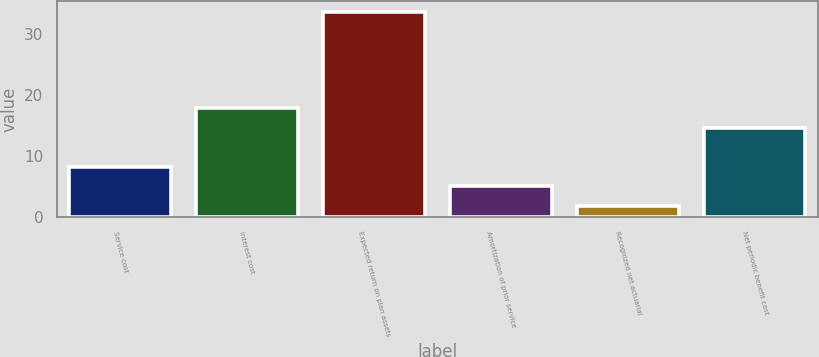Convert chart to OTSL. <chart><loc_0><loc_0><loc_500><loc_500><bar_chart><fcel>Service cost<fcel>Interest cost<fcel>Expected return on plan assets<fcel>Amortization of prior service<fcel>Recognized net actuarial<fcel>Net periodic benefit cost<nl><fcel>8.26<fcel>17.88<fcel>33.7<fcel>5.08<fcel>1.9<fcel>14.7<nl></chart> 